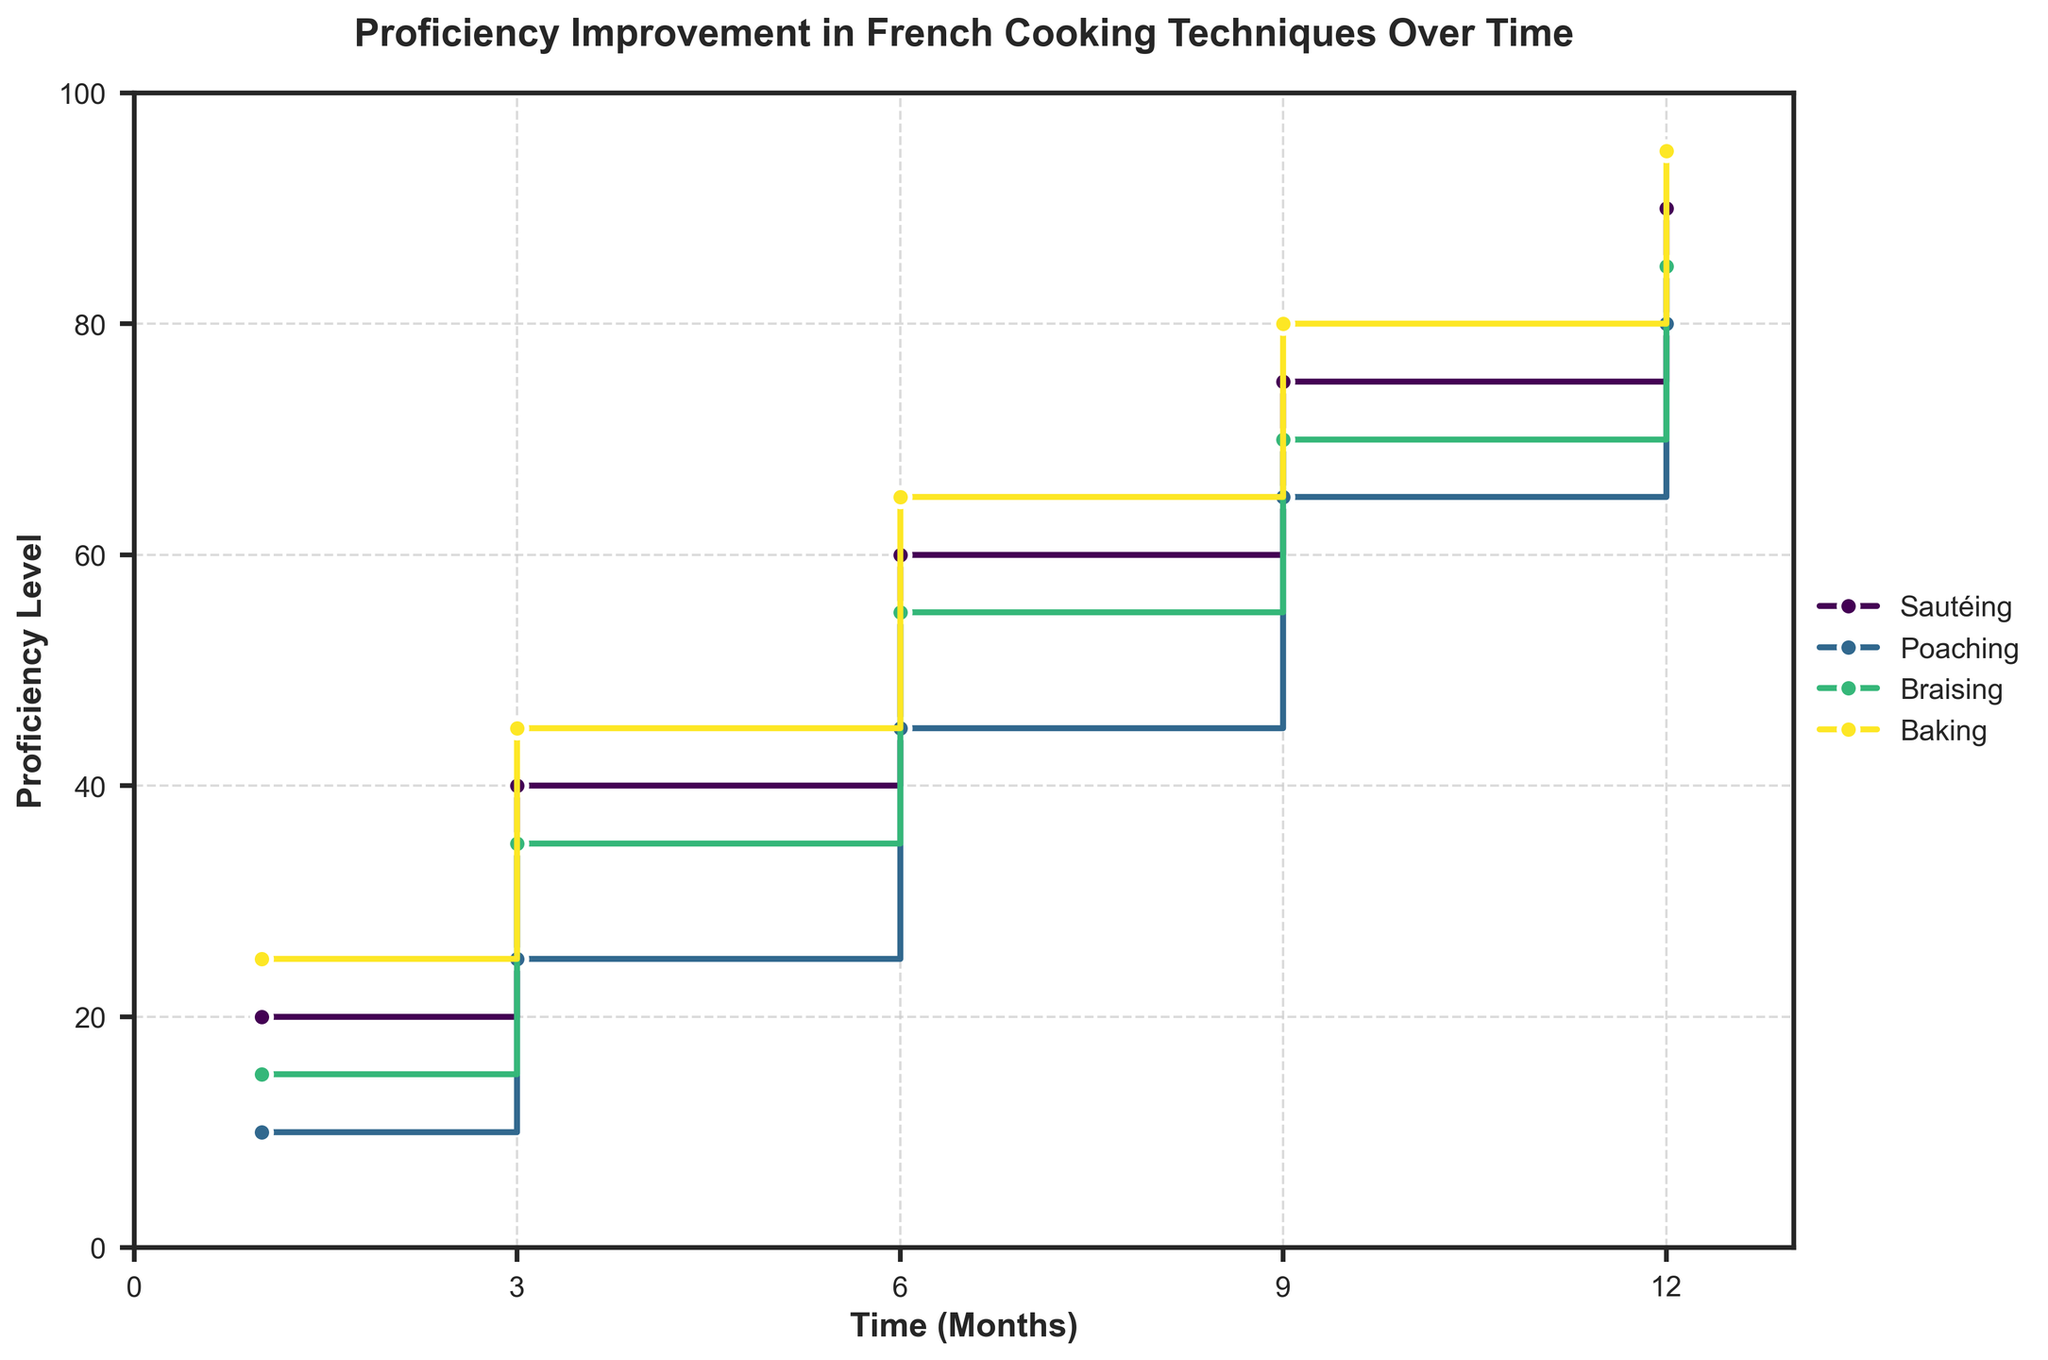What is the title of the plot? The title of the plot is found at the top center and provides a summary of the plot's subject. Here it is, "Proficiency Improvement in French Cooking Techniques Over Time".
Answer: Proficiency Improvement in French Cooking Techniques Over Time Which cooking technique shows the highest proficiency level after 12 months? To determine this, look at each group's final proficiency level at the 12-month mark. The highest value among them is 95 for Baking.
Answer: Baking How does the proficiency level of Sautéing change between 1 month and 12 months? Look at the proficiency level for Sautéing at 1 month and at 12 months. It starts at 20 and increases to 90. The change is 90 - 20 = 70.
Answer: It increases by 70 points Which cooking technique shows the greatest improvement from 1 month to 6 months? Calculate the difference in proficiency from 1 month to 6 months for each technique. Sautéing: 60-20=40, Poaching: 45-10=35, Braising: 55-15=40, Baking: 65-25=40. Sautéing, Braising, and Baking each show a 40-point improvement, which is the greatest.
Answer: Sautéing, Braising, Baking Compare the proficiency levels of Poaching and Braising at 9 months. Which one is higher? Look at the proficiency levels for both Poaching and Braising at 9 months. Poaching is at 65, while Braising is at 70.
Answer: Braising What is the average proficiency level for Baking over the 12-month period? Sum all proficiency levels for Baking (25 + 45 + 65 + 80 + 95) and divide by the number of time points (5). (25+45+65+80+95)=310. 310/5=62.
Answer: 62 How many cooking techniques reach a proficiency level of at least 80 by the 12th month? Check the proficiency levels at the 12th month for each technique. Sautéing: 90, Poaching: 80, Braising: 85, Baking: 95. All four techniques reach at least 80.
Answer: Four At which time points does Sautéing see a significant increase in proficiency level? Look for the time intervals where Sautéing's proficiency level increases notably. Significant increases occur between 3 and 6 months (40 to 60, 20-point increase), and 9 to 12 months (75 to 90, 15-point increase).
Answer: 3 to 6 months, 9 to 12 months Which cooking technique starts with the highest proficiency level at 1 month? Compare the initial proficiency levels of all techniques at 1 month. Baking starts with the highest proficiency level at 25.
Answer: Baking 